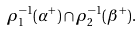<formula> <loc_0><loc_0><loc_500><loc_500>\rho _ { 1 } ^ { - 1 } ( \alpha ^ { + } ) \cap \rho _ { 2 } ^ { - 1 } ( \beta ^ { + } ) .</formula> 